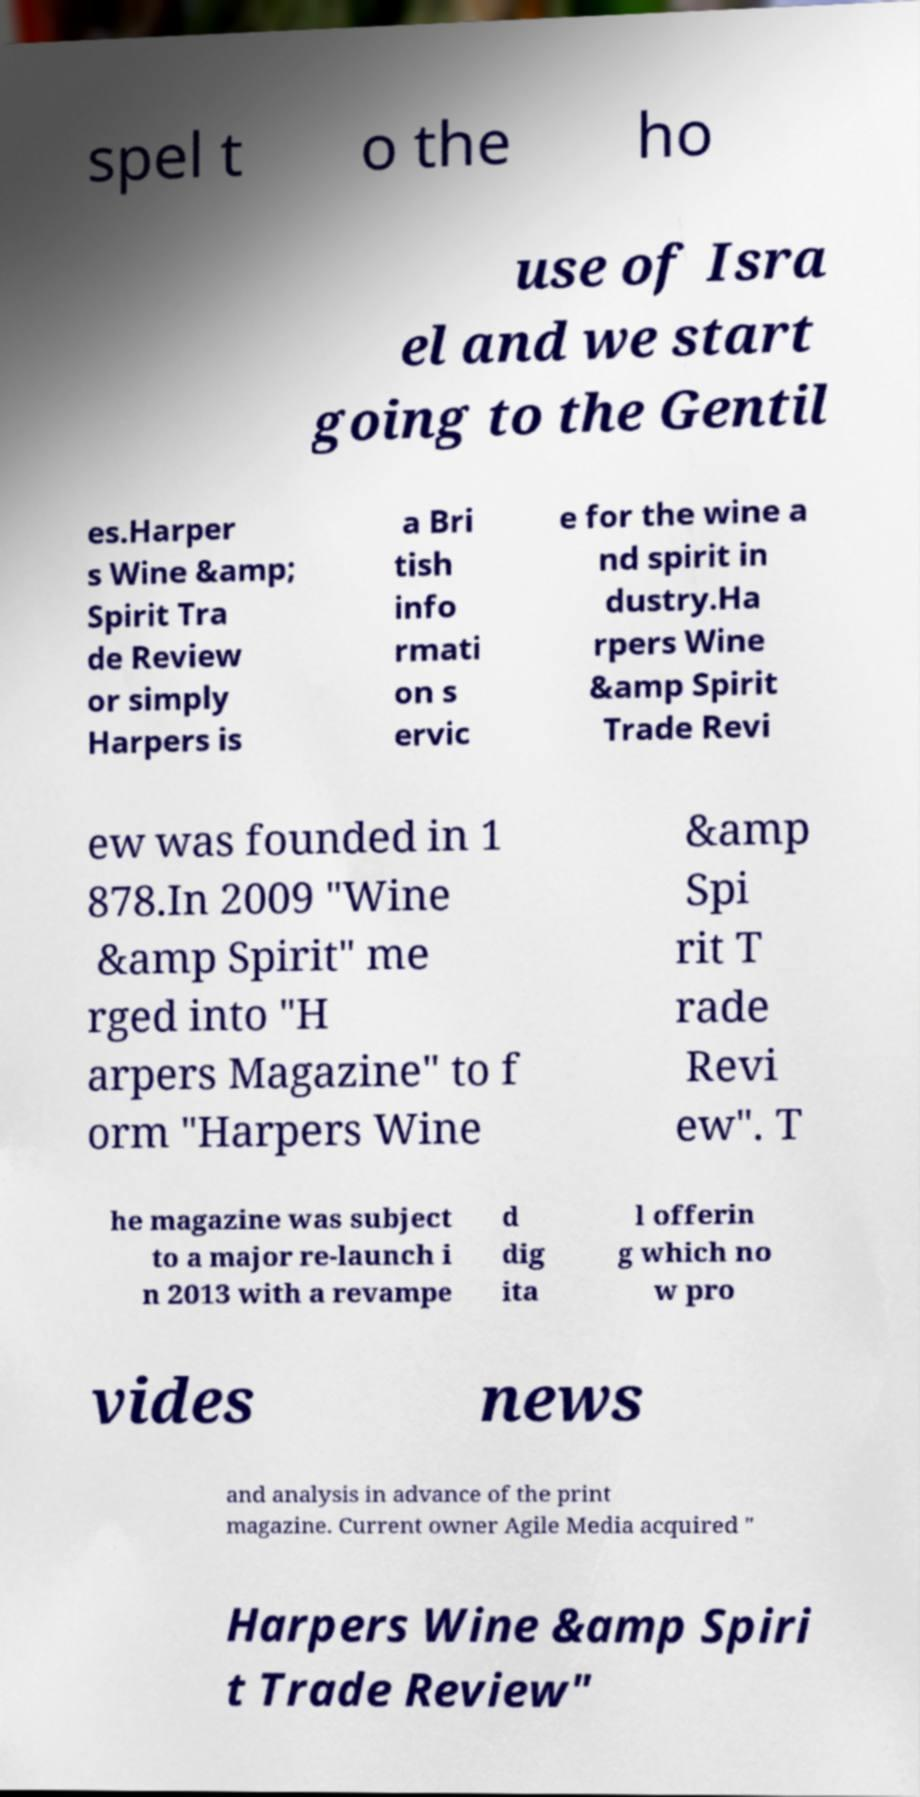What messages or text are displayed in this image? I need them in a readable, typed format. spel t o the ho use of Isra el and we start going to the Gentil es.Harper s Wine &amp; Spirit Tra de Review or simply Harpers is a Bri tish info rmati on s ervic e for the wine a nd spirit in dustry.Ha rpers Wine &amp Spirit Trade Revi ew was founded in 1 878.In 2009 "Wine &amp Spirit" me rged into "H arpers Magazine" to f orm "Harpers Wine &amp Spi rit T rade Revi ew". T he magazine was subject to a major re-launch i n 2013 with a revampe d dig ita l offerin g which no w pro vides news and analysis in advance of the print magazine. Current owner Agile Media acquired " Harpers Wine &amp Spiri t Trade Review" 